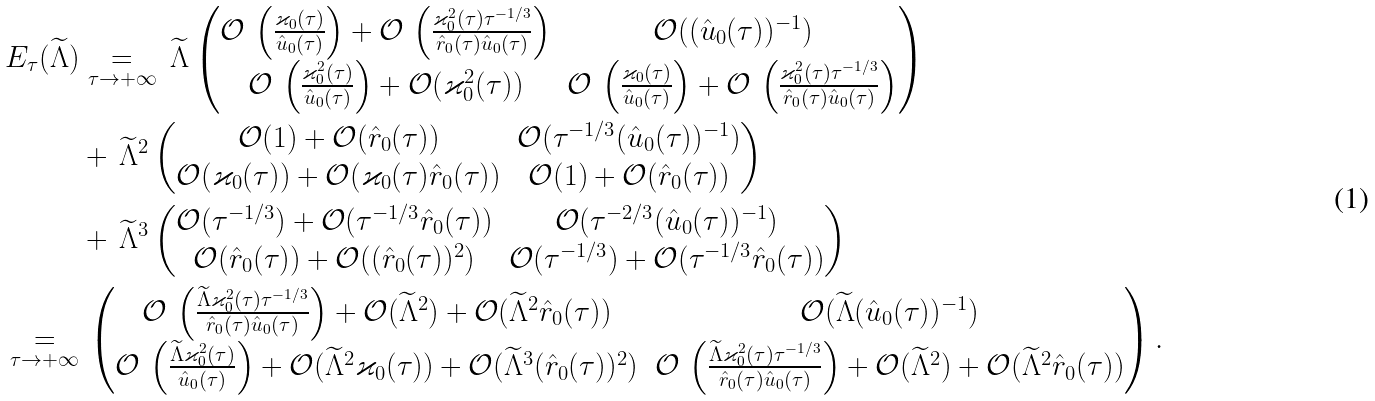Convert formula to latex. <formula><loc_0><loc_0><loc_500><loc_500>E _ { \tau } ( \widetilde { \Lambda } ) & \underset { \tau \to + \infty } { = } \, \widetilde { \Lambda } \begin{pmatrix} \mathcal { O } \, \left ( \frac { \varkappa _ { 0 } ( \tau ) } { \hat { u } _ { 0 } ( \tau ) } \right ) + \mathcal { O } \, \left ( \frac { \varkappa _ { 0 } ^ { 2 } ( \tau ) \tau ^ { - 1 / 3 } } { \hat { r } _ { 0 } ( \tau ) \hat { u } _ { 0 } ( \tau ) } \right ) & \mathcal { O } ( ( \hat { u } _ { 0 } ( \tau ) ) ^ { - 1 } ) \\ \mathcal { O } \, \left ( \frac { \varkappa _ { 0 } ^ { 2 } ( \tau ) } { \hat { u } _ { 0 } ( \tau ) } \right ) + \mathcal { O } ( \varkappa _ { 0 } ^ { 2 } ( \tau ) ) & \mathcal { O } \, \left ( \frac { \varkappa _ { 0 } ( \tau ) } { \hat { u } _ { 0 } ( \tau ) } \right ) + \mathcal { O } \, \left ( \frac { \varkappa _ { 0 } ^ { 2 } ( \tau ) \tau ^ { - 1 / 3 } } { \hat { r } _ { 0 } ( \tau ) \hat { u } _ { 0 } ( \tau ) } \right ) \end{pmatrix} \\ & + \, \widetilde { \Lambda } ^ { 2 } \begin{pmatrix} \mathcal { O } ( 1 ) + \mathcal { O } ( \hat { r } _ { 0 } ( \tau ) ) & \mathcal { O } ( \tau ^ { - 1 / 3 } ( \hat { u } _ { 0 } ( \tau ) ) ^ { - 1 } ) \\ \mathcal { O } ( \varkappa _ { 0 } ( \tau ) ) + \mathcal { O } ( \varkappa _ { 0 } ( \tau ) \hat { r } _ { 0 } ( \tau ) ) & \mathcal { O } ( 1 ) + \mathcal { O } ( \hat { r } _ { 0 } ( \tau ) ) \end{pmatrix} \\ & + \, \widetilde { \Lambda } ^ { 3 } \begin{pmatrix} \mathcal { O } ( \tau ^ { - 1 / 3 } ) + \mathcal { O } ( \tau ^ { - 1 / 3 } \hat { r } _ { 0 } ( \tau ) ) & \mathcal { O } ( \tau ^ { - 2 / 3 } ( \hat { u } _ { 0 } ( \tau ) ) ^ { - 1 } ) \\ \mathcal { O } ( \hat { r } _ { 0 } ( \tau ) ) + \mathcal { O } ( ( \hat { r } _ { 0 } ( \tau ) ) ^ { 2 } ) & \mathcal { O } ( \tau ^ { - 1 / 3 } ) + \mathcal { O } ( \tau ^ { - 1 / 3 } \hat { r } _ { 0 } ( \tau ) ) \end{pmatrix} \\ \underset { \tau \to + \infty } { = } & \, \begin{pmatrix} \mathcal { O } \, \left ( \frac { \widetilde { \Lambda } \varkappa _ { 0 } ^ { 2 } ( \tau ) \tau ^ { - 1 / 3 } } { \hat { r } _ { 0 } ( \tau ) \hat { u } _ { 0 } ( \tau ) } \right ) + \mathcal { O } ( \widetilde { \Lambda } ^ { 2 } ) + \mathcal { O } ( \widetilde { \Lambda } ^ { 2 } \hat { r } _ { 0 } ( \tau ) ) & \mathcal { O } ( \widetilde { \Lambda } ( \hat { u } _ { 0 } ( \tau ) ) ^ { - 1 } ) \\ \mathcal { O } \, \left ( \frac { \widetilde { \Lambda } \varkappa _ { 0 } ^ { 2 } ( \tau ) } { \hat { u } _ { 0 } ( \tau ) } \right ) + \mathcal { O } ( \widetilde { \Lambda } ^ { 2 } \varkappa _ { 0 } ( \tau ) ) + \mathcal { O } ( \widetilde { \Lambda } ^ { 3 } ( \hat { r } _ { 0 } ( \tau ) ) ^ { 2 } ) & \mathcal { O } \, \left ( \frac { \widetilde { \Lambda } \varkappa _ { 0 } ^ { 2 } ( \tau ) \tau ^ { - 1 / 3 } } { \hat { r } _ { 0 } ( \tau ) \hat { u } _ { 0 } ( \tau ) } \right ) + \mathcal { O } ( \widetilde { \Lambda } ^ { 2 } ) + \mathcal { O } ( \widetilde { \Lambda } ^ { 2 } \hat { r } _ { 0 } ( \tau ) ) \end{pmatrix} .</formula> 